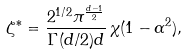<formula> <loc_0><loc_0><loc_500><loc_500>\zeta ^ { \ast } = \frac { 2 ^ { 1 / 2 } \pi ^ { \frac { d - 1 } { 2 } } } { \Gamma ( d / 2 ) d } \, \chi ( 1 - \alpha ^ { 2 } ) ,</formula> 